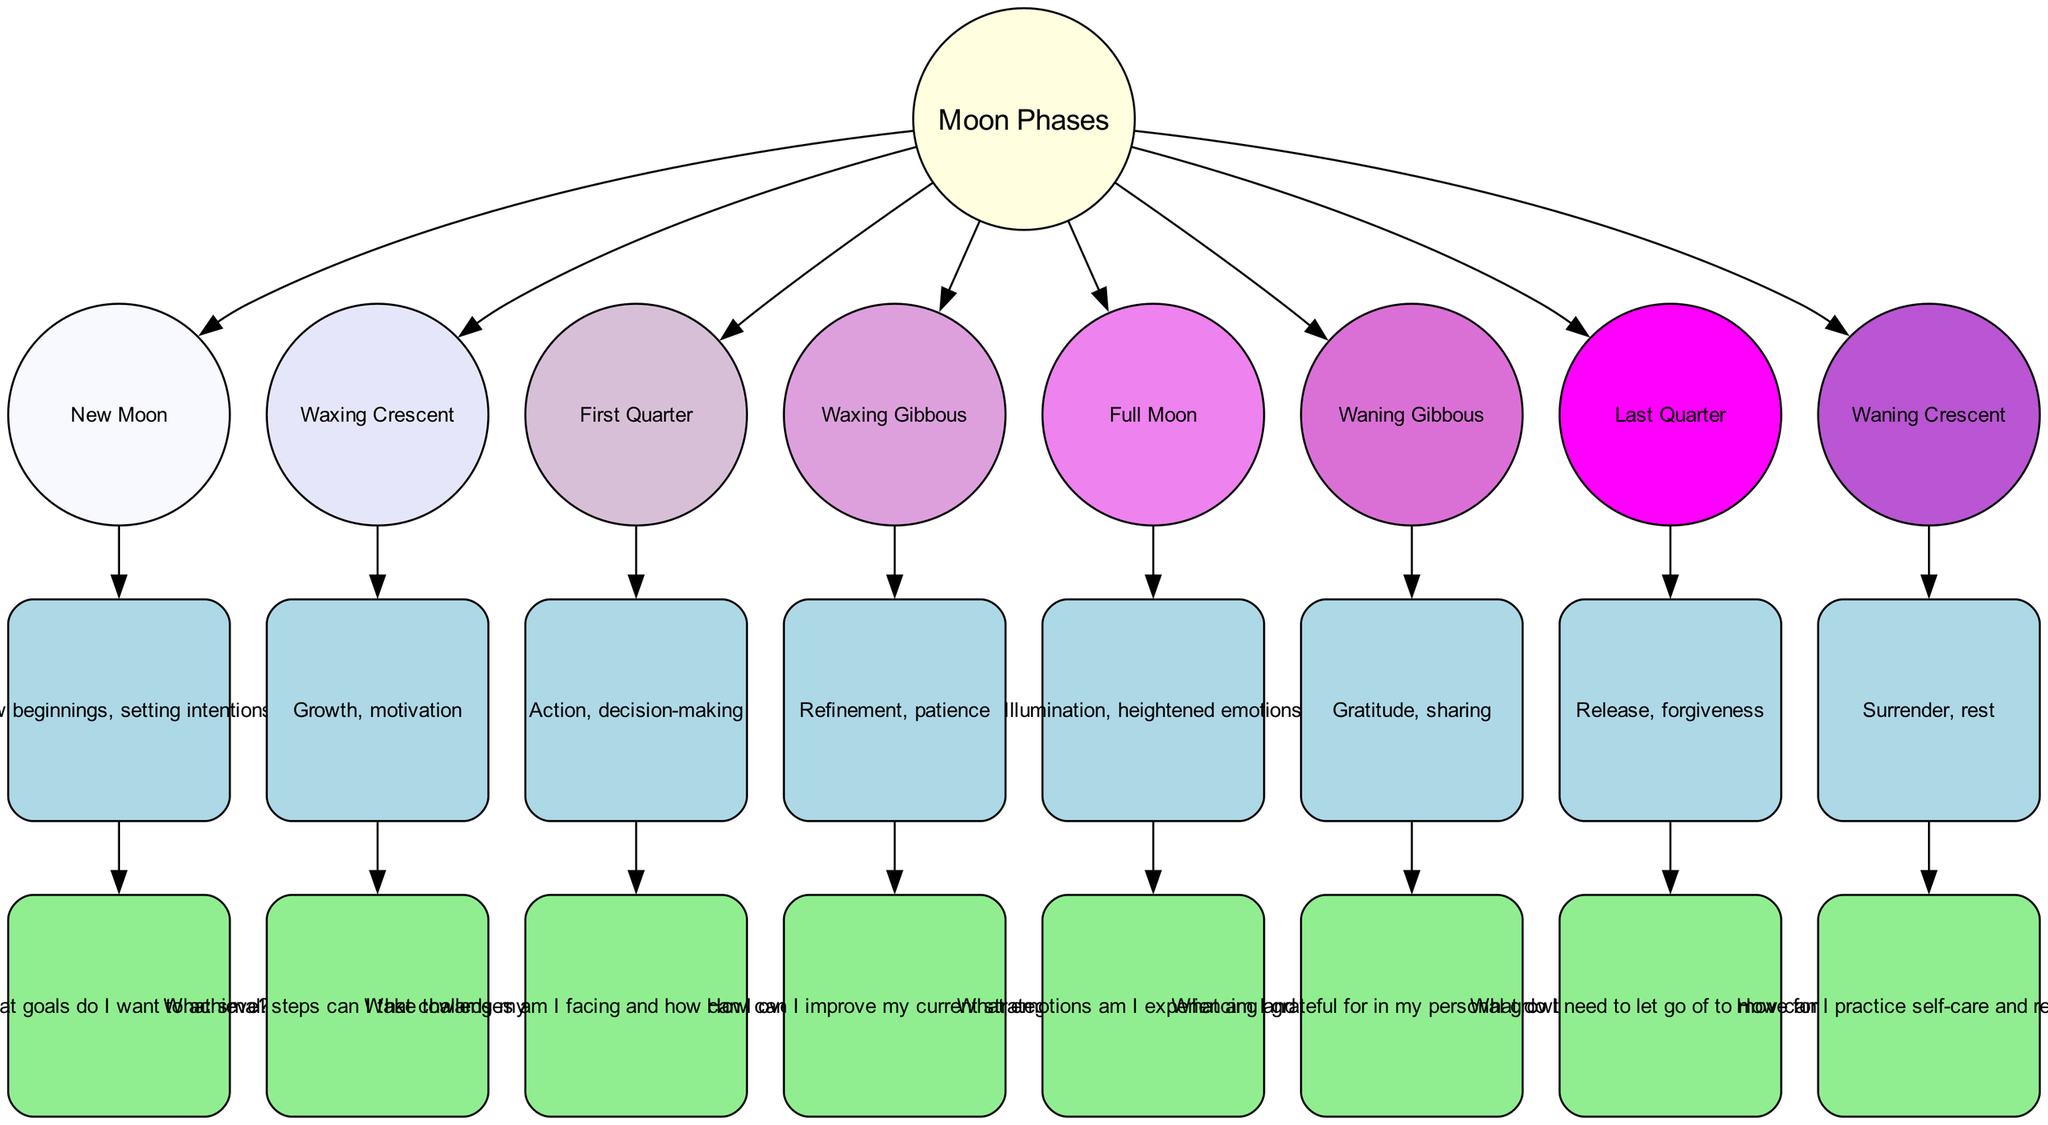What is the first moon phase in the diagram? The first node in the list of moon phases is the "New Moon," as it is the first item in the phases array.
Answer: New Moon What is the traditional association of the Full Moon? The Full Moon phase connects to an association labeled "Illumination, heightened emotions," which is directly linked to the node representing the Full Moon.
Answer: Illumination, heightened emotions How many total moon phases are displayed in the diagram? By counting the number of moon phases listed in the phases array, which includes eight separate entries, we find that there are eight phases.
Answer: Eight What emotional reflection is associated with the Waxing Crescent? The reflection question linked to the Waxing Crescent is "What small steps can I take towards my goals?" This is shown beneath the association for the Waxing Crescent phase.
Answer: What small steps can I take towards my goals? What do you need to let go of during the Last Quarter? The reflection for the Last Quarter mentions "What do I need to let go of to move forward?" This directly addresses what someone might need to release at this phase.
Answer: What do I need to let go of to move forward? What is the association of the Waning Crescent phase? The Waning Crescent phase connects to the association "Surrender, rest." This tells us what emotional or personal state is highlighted for this particular phase.
Answer: Surrender, rest In which phase should one focus on refinement and patience? The diagram connects the concept of refinement and patience to the "Waxing Gibbous" phase, indicating this is the time for such emotional focuses.
Answer: Waxing Gibbous How does the change from New Moon to Full Moon conceptually represent a personal journey? The transition illustrates a journey from setting intentions at the New Moon to embracing heightened emotions and personal insights during the Full Moon, exhibiting growth and evolution across phases.
Answer: Growth and evolution across phases 